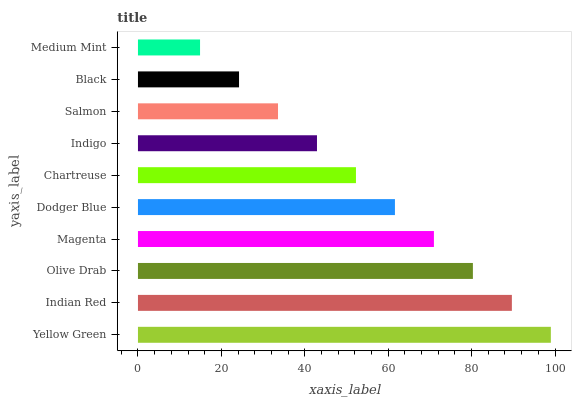Is Medium Mint the minimum?
Answer yes or no. Yes. Is Yellow Green the maximum?
Answer yes or no. Yes. Is Indian Red the minimum?
Answer yes or no. No. Is Indian Red the maximum?
Answer yes or no. No. Is Yellow Green greater than Indian Red?
Answer yes or no. Yes. Is Indian Red less than Yellow Green?
Answer yes or no. Yes. Is Indian Red greater than Yellow Green?
Answer yes or no. No. Is Yellow Green less than Indian Red?
Answer yes or no. No. Is Dodger Blue the high median?
Answer yes or no. Yes. Is Chartreuse the low median?
Answer yes or no. Yes. Is Magenta the high median?
Answer yes or no. No. Is Olive Drab the low median?
Answer yes or no. No. 